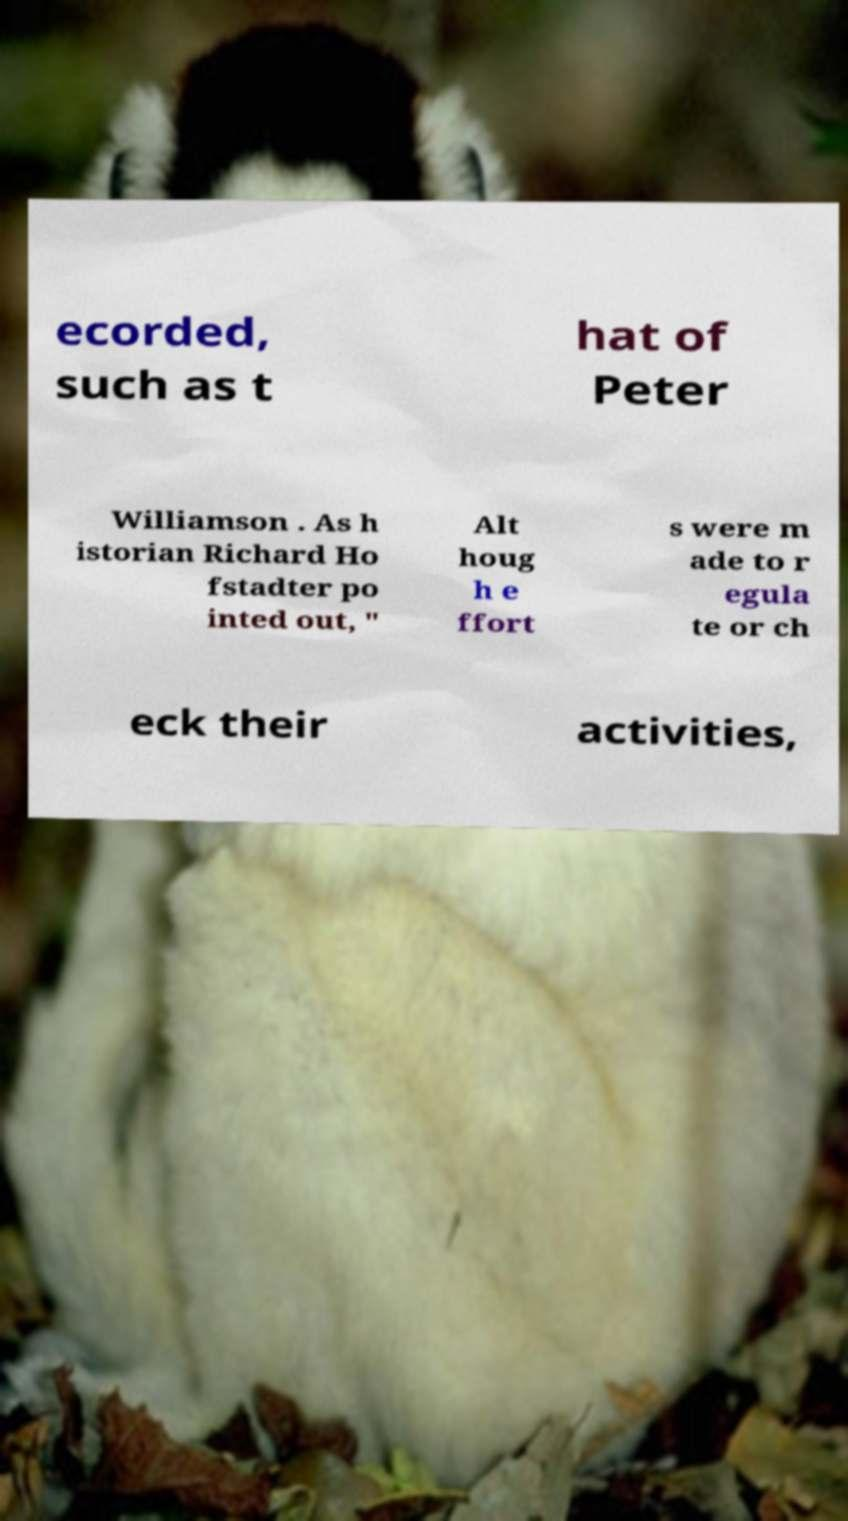Can you accurately transcribe the text from the provided image for me? ecorded, such as t hat of Peter Williamson . As h istorian Richard Ho fstadter po inted out, " Alt houg h e ffort s were m ade to r egula te or ch eck their activities, 